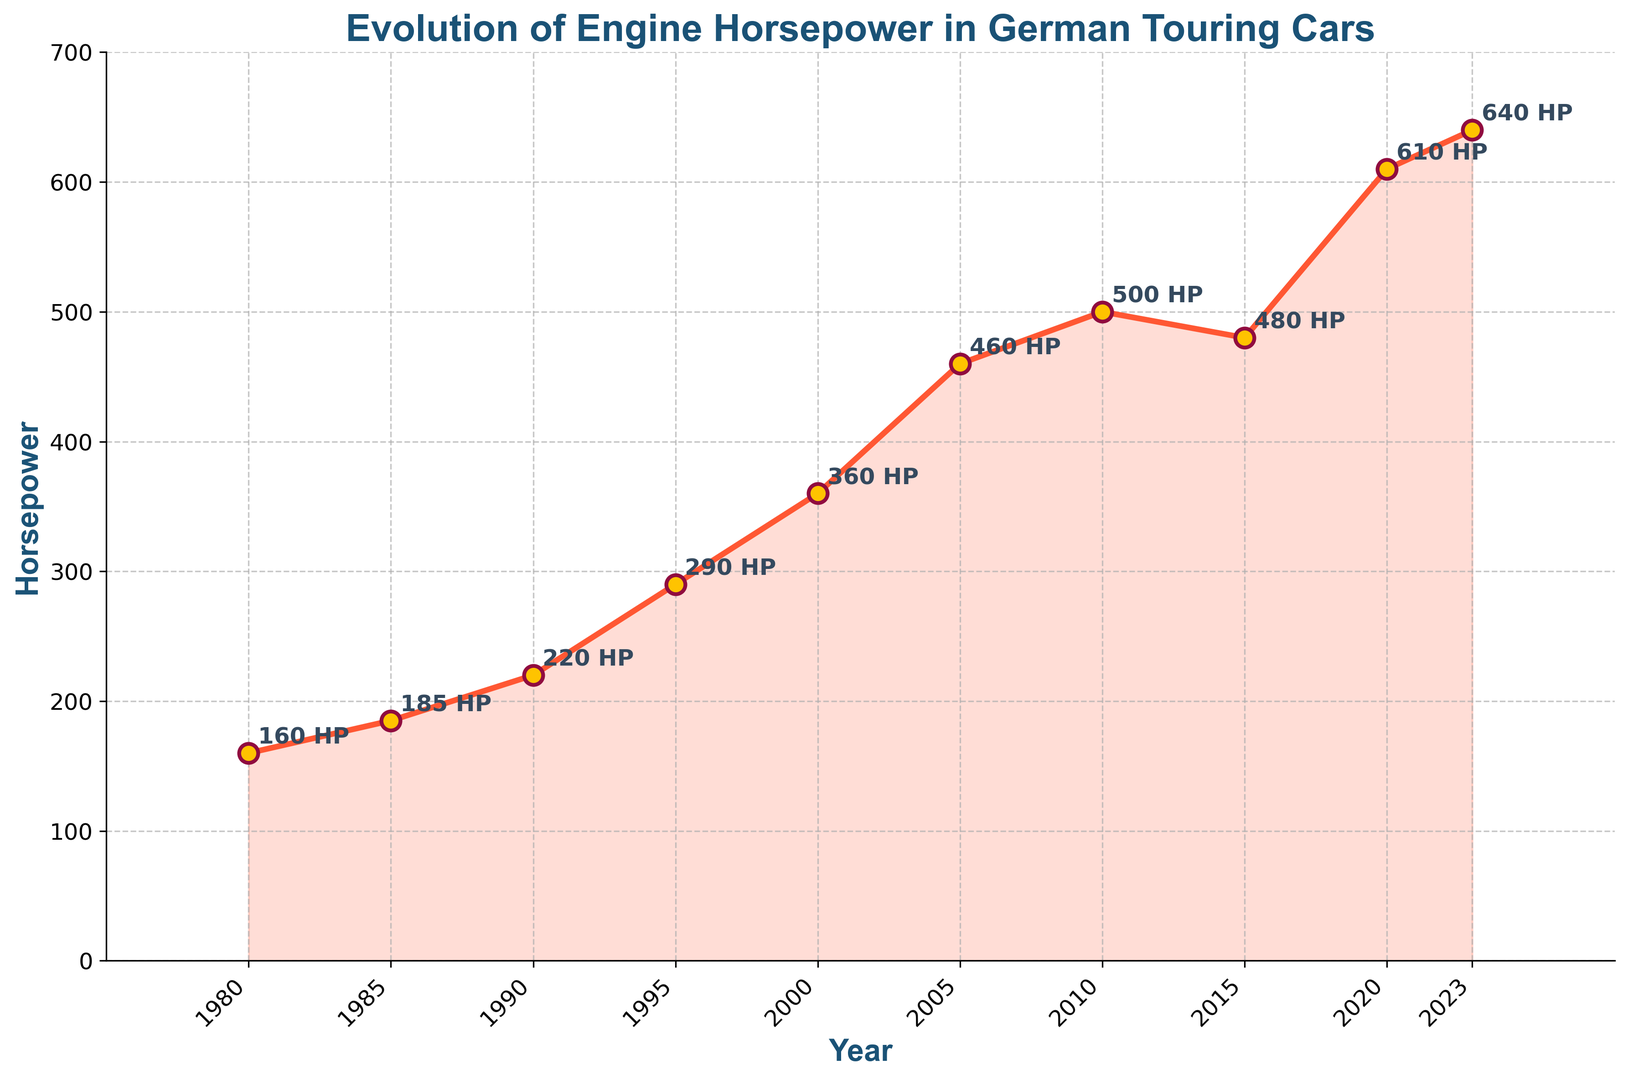What was the horsepower of German touring cars in 2000? The figure has a labeled point for each year. In 2000, the horsepower is specifically marked as '360 HP'.
Answer: 360 HP Which year saw the greatest increase in horsepower compared to the previous milestone on the chart? By examining the slope and the annotations, the greatest increase in horsepower appears between 2015 (480 HP) and 2020 (610 HP), which is an increase of 130 HP.
Answer: Between 2015 and 2020 How much horsepower did German touring cars gain between the 1980s and the 1990s? The horsepower in 1980 is 160 HP and in 1990 it is 220 HP. The gain can be calculated as 220 HP - 160 HP.
Answer: 60 HP In which year did the horsepower exceed 500 for the first time? The figure shows 500 HP in 2010, so the horsepower exceeded 500 for the first time in the year 2020 when it reached 610 HP.
Answer: 2020 What is the average horsepower of German touring cars from 1980 to 2023? Add the horsepower values for each year: 160 + 185 + 220 + 290 + 360 + 460 + 500 + 480 + 610 + 640 = 3905. Then divide by the number of points (10): 3905 / 10 = 390.5.
Answer: 390.5 HP In terms of horsepower, how does the year 1995 compare to the year 2023? In 1995, horsepower was 290 HP, and in 2023 it is 640 HP. Compare these values directly: 640 - 290 = 350. There is a 350 HP increase.
Answer: 1995 has 350 HP less than 2023 Which decade showed the smallest increase in horsepower? By comparing the slopes and values, the decade from 2015 (480 HP) to 2023 (640 HP) increased by 160 HP, and the decade from 1990 (220 HP) to 2000 (360 HP) increased by 140 HP. The smallest increase is from 1980 to 1990 (60 HP).
Answer: 1980s What color are the data points marked with? The figure shows that the data points are marked in a red-orange color with yellow center faces and dark red edges.
Answer: Red-orange with yellow centers How does the horsepower in 2010 compare to 2005? In 2005, the horsepower is 460 HP, and in 2010, it is 500 HP. This gives an increase: 500 HP - 460 HP.
Answer: 40 HP increase 